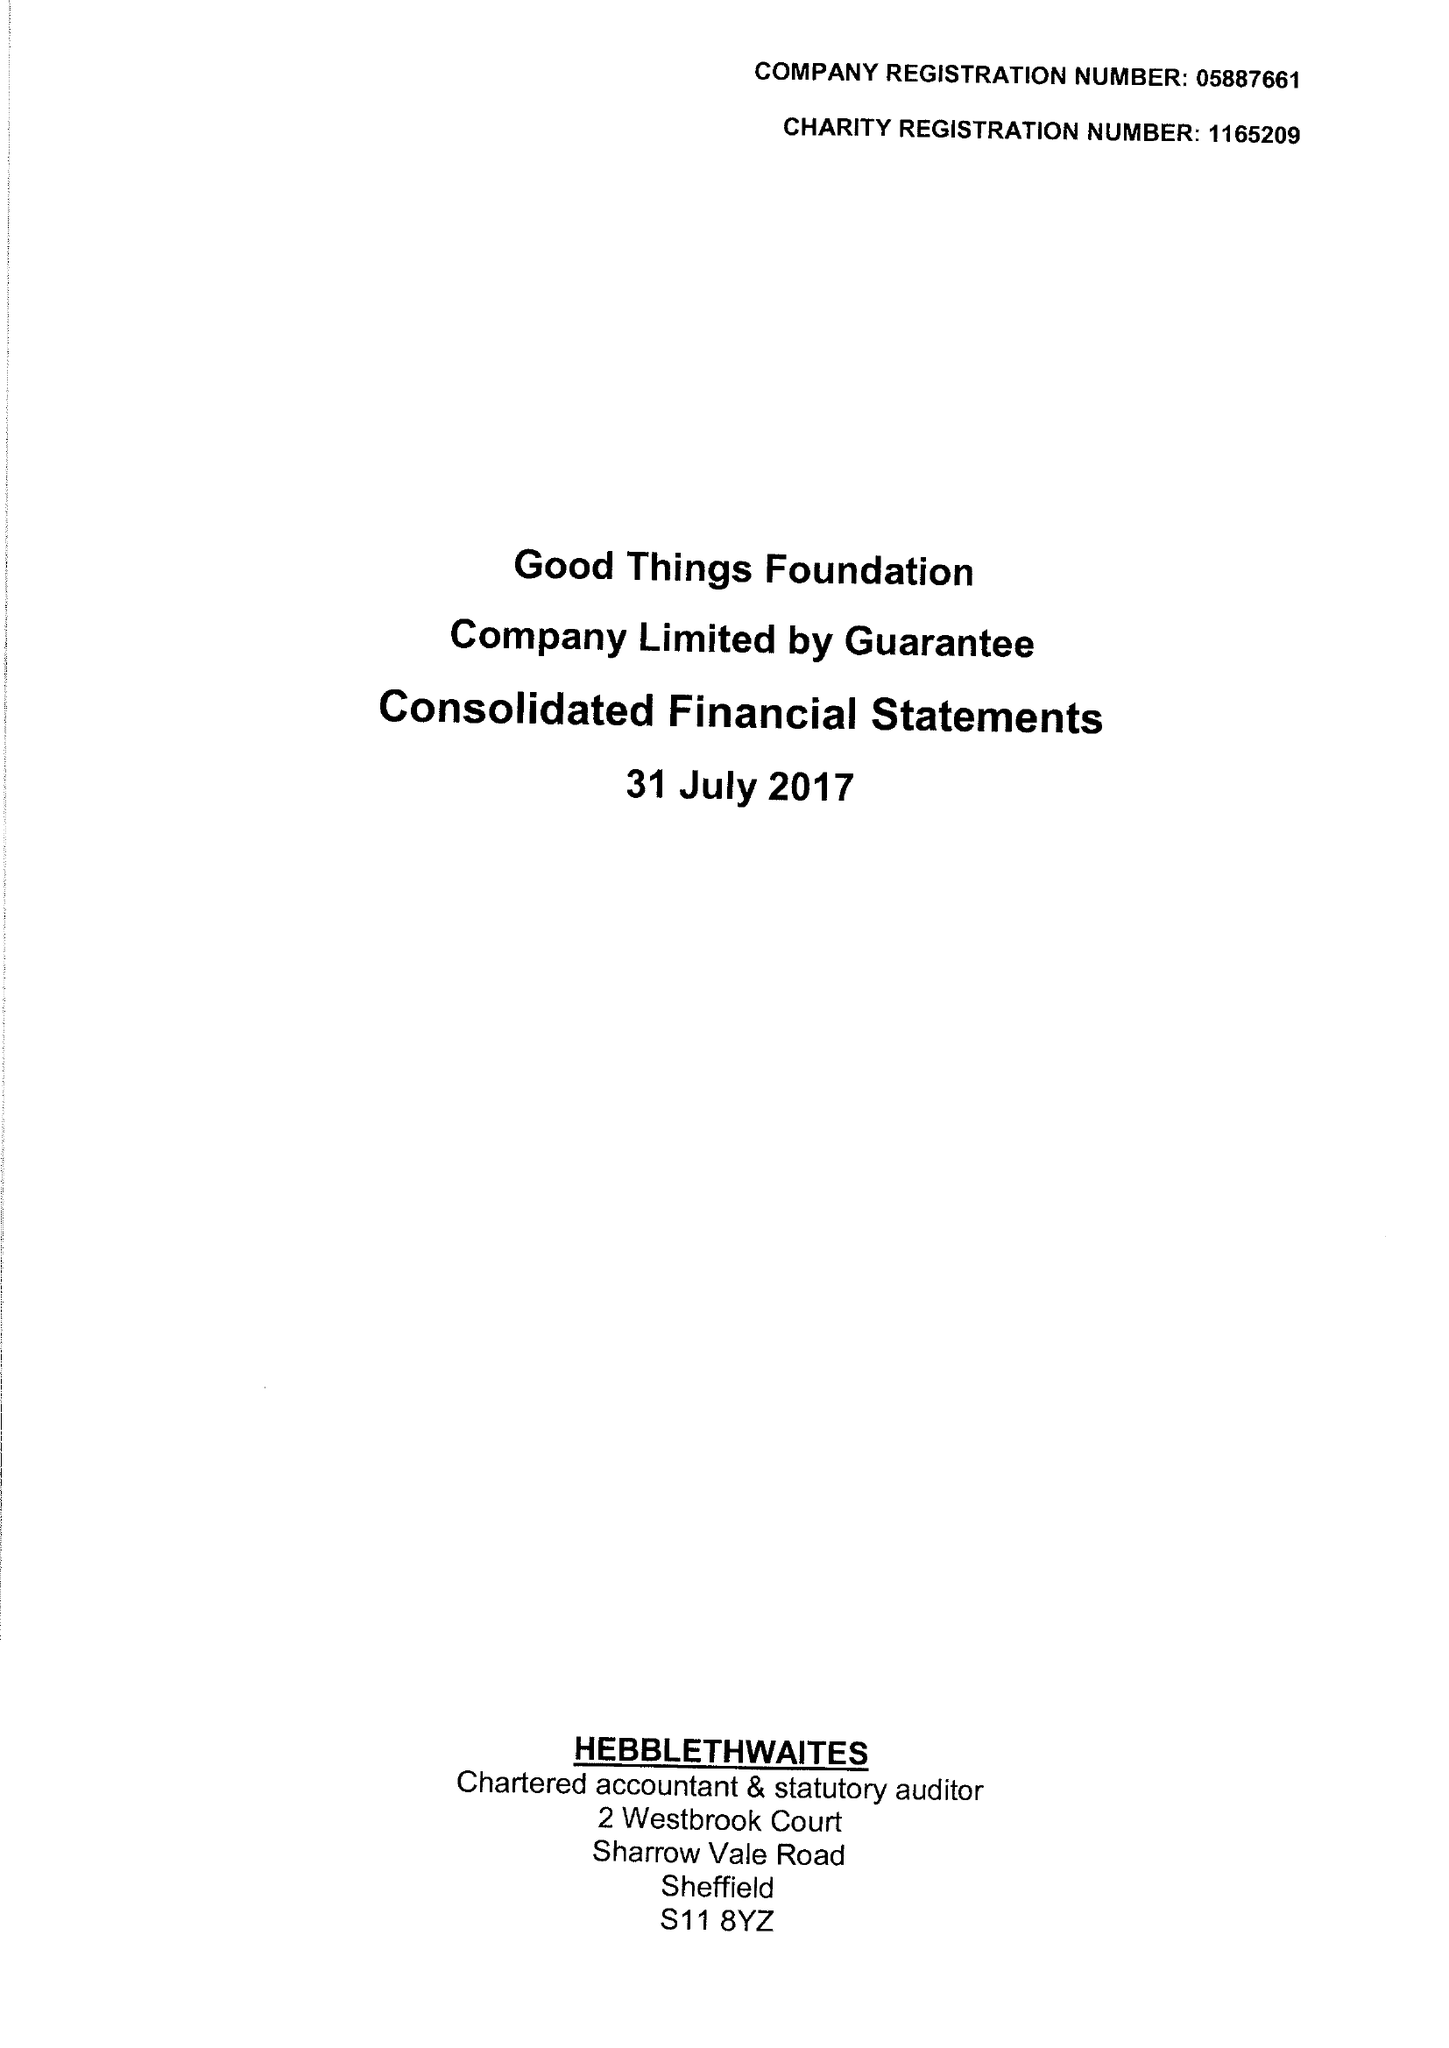What is the value for the charity_name?
Answer the question using a single word or phrase. Good Things Foundation 